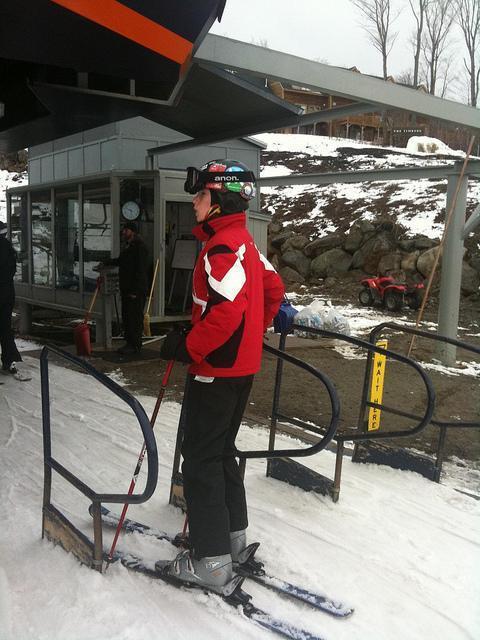How many people are on the red ATV?
Give a very brief answer. 0. How many people are in the picture?
Give a very brief answer. 3. 